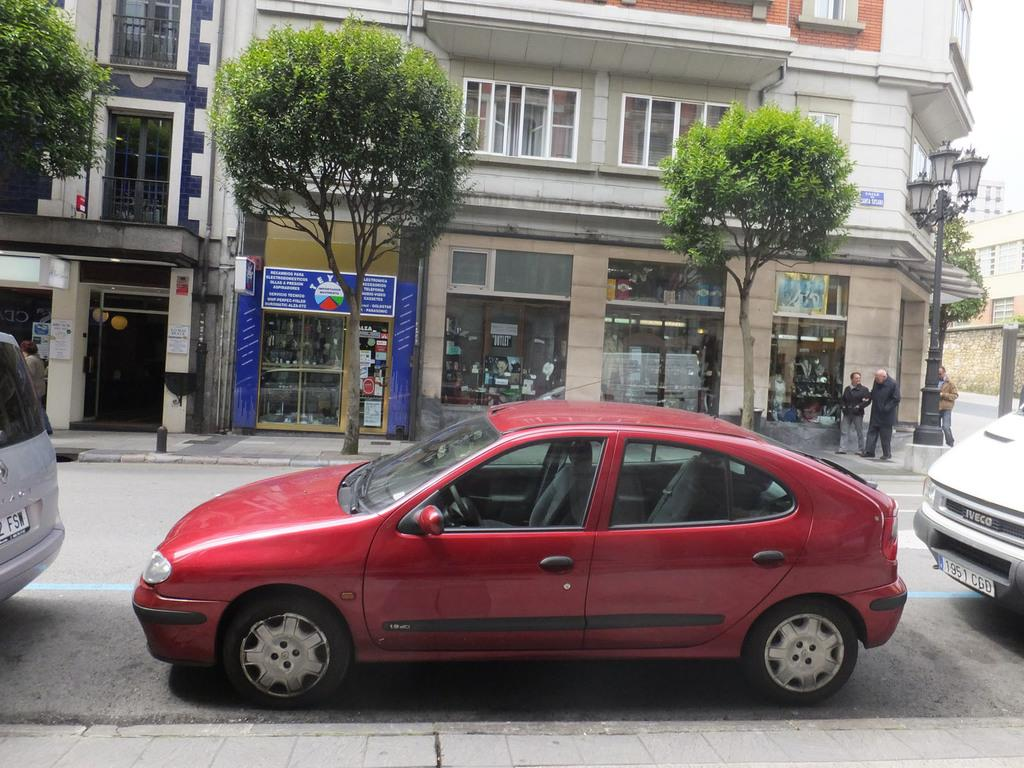What can be seen on the road in the image? There are vehicles on the road in the image. What is located in front of the building in the image? There are trees in front of a building in the image. What object can be seen standing upright in the image? There is a pole in the image. Where are the persons located in the image? The persons are on the right side of the image. Can you hear the hen laughing in the image? There is no hen present in the image, and therefore no such activity can be heard. What type of destruction is visible in the image? There is no destruction visible in the image; it features vehicles on the road, trees in front of a building, a pole, and persons on the right side. 